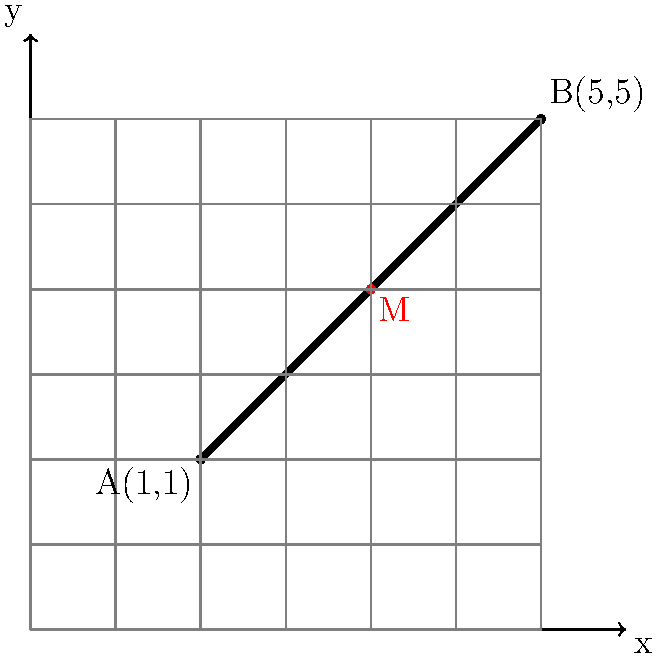At the St. Clair skate park, there's a diagonal rail that runs from point A(1,1) to point B(5,5) on the coordinate grid. You want to perform a trick exactly at the midpoint of this rail. Using coordinate geometry, determine the coordinates of the midpoint M of the rail AB. To find the midpoint of a line segment using coordinate geometry, we can use the midpoint formula:

$$ M_x = \frac{x_1 + x_2}{2}, M_y = \frac{y_1 + y_2}{2} $$

Where $(x_1, y_1)$ and $(x_2, y_2)$ are the coordinates of the endpoints of the line segment.

Given:
- Point A: $(1, 1)$
- Point B: $(5, 5)$

Step 1: Calculate the x-coordinate of the midpoint:
$$ M_x = \frac{x_1 + x_2}{2} = \frac{1 + 5}{2} = \frac{6}{2} = 3 $$

Step 2: Calculate the y-coordinate of the midpoint:
$$ M_y = \frac{y_1 + y_2}{2} = \frac{1 + 5}{2} = \frac{6}{2} = 3 $$

Therefore, the coordinates of the midpoint M are $(3, 3)$.
Answer: $(3, 3)$ 